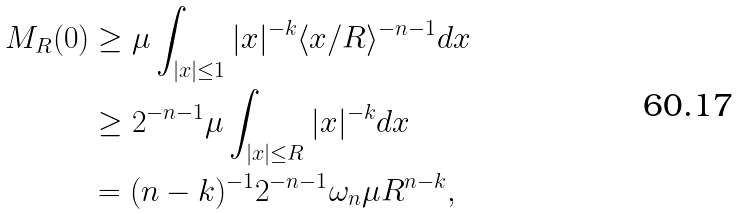<formula> <loc_0><loc_0><loc_500><loc_500>M _ { R } ( 0 ) & \geq \mu \int _ { | x | \leq 1 } | x | ^ { - k } \langle x / R \rangle ^ { - n - 1 } d x \\ & \geq 2 ^ { - n - 1 } \mu \int _ { | x | \leq R } | x | ^ { - k } d x \\ & = ( n - k ) ^ { - 1 } 2 ^ { - n - 1 } \omega _ { n } \mu R ^ { n - k } ,</formula> 